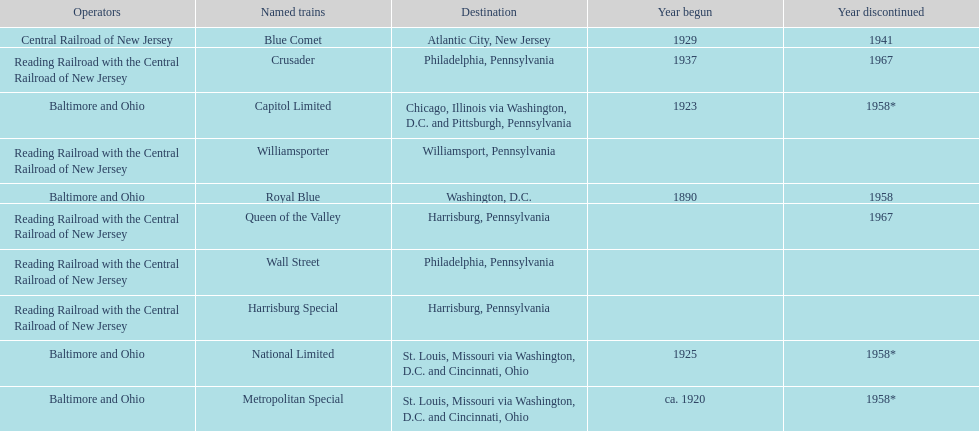What was the first train to begin service? Royal Blue. 